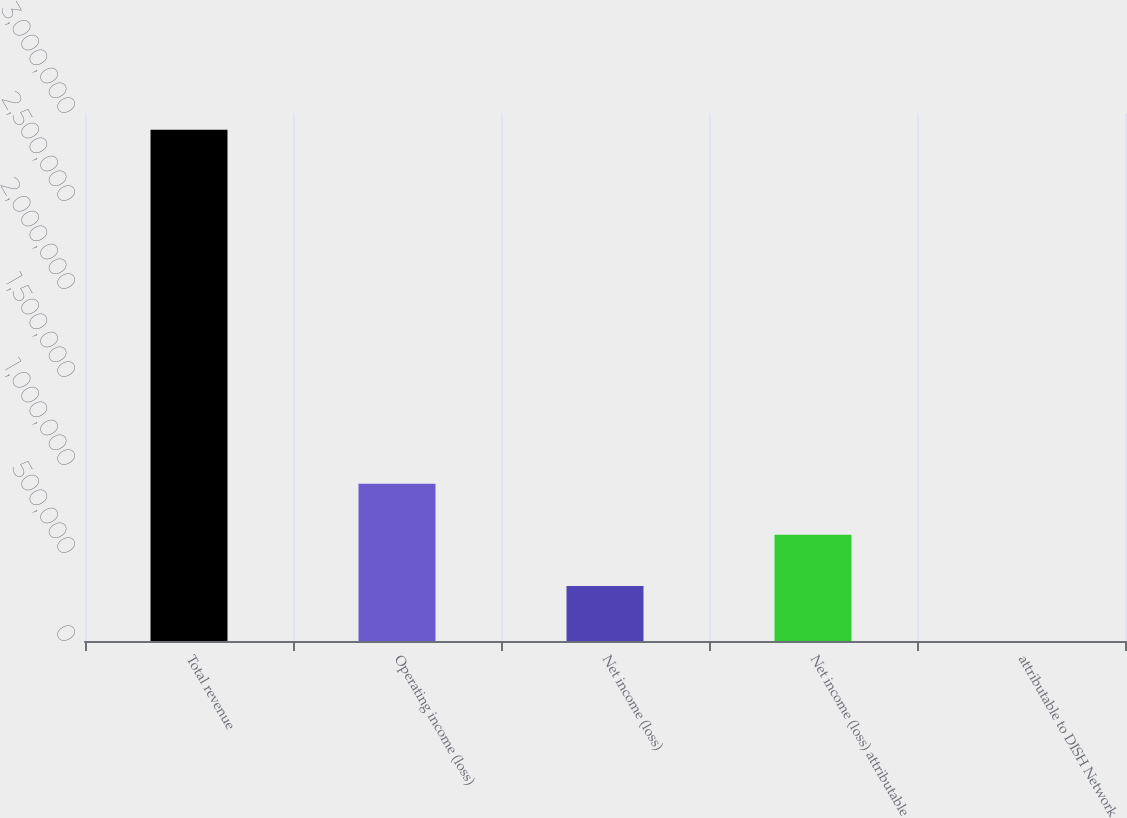Convert chart. <chart><loc_0><loc_0><loc_500><loc_500><bar_chart><fcel>Total revenue<fcel>Operating income (loss)<fcel>Net income (loss)<fcel>Net income (loss) attributable<fcel>attributable to DISH Network<nl><fcel>2.90532e+06<fcel>893748<fcel>312684<fcel>603216<fcel>0.7<nl></chart> 